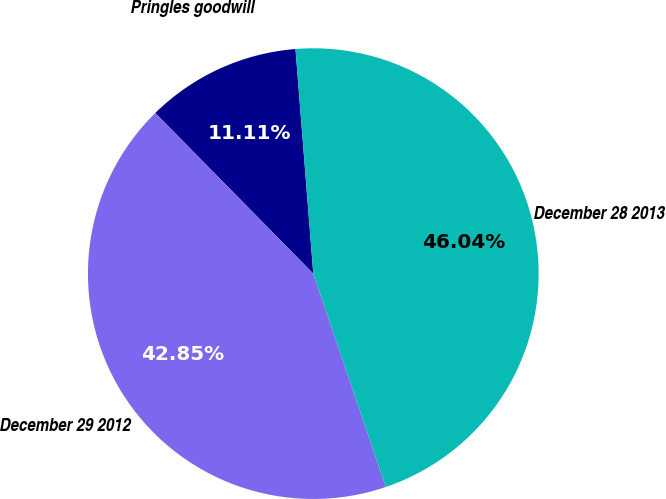<chart> <loc_0><loc_0><loc_500><loc_500><pie_chart><fcel>Pringles goodwill<fcel>December 29 2012<fcel>December 28 2013<nl><fcel>11.11%<fcel>42.85%<fcel>46.04%<nl></chart> 